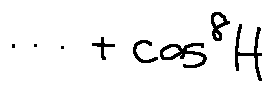<formula> <loc_0><loc_0><loc_500><loc_500>\cdots + \cos ^ { 8 } H</formula> 